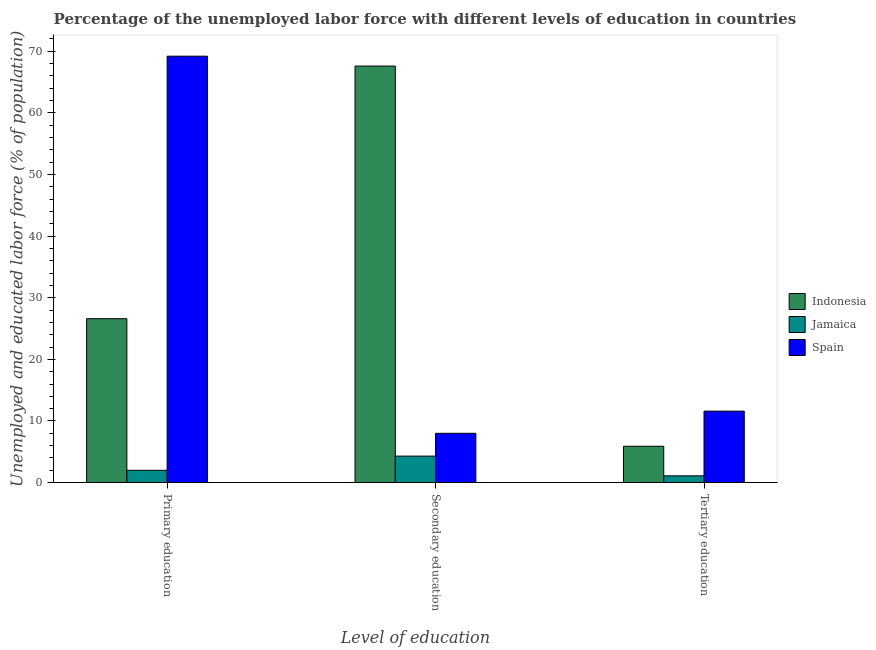How many different coloured bars are there?
Offer a terse response. 3. Are the number of bars per tick equal to the number of legend labels?
Keep it short and to the point. Yes. Are the number of bars on each tick of the X-axis equal?
Keep it short and to the point. Yes. How many bars are there on the 2nd tick from the right?
Offer a very short reply. 3. What is the label of the 3rd group of bars from the left?
Ensure brevity in your answer.  Tertiary education. What is the percentage of labor force who received primary education in Jamaica?
Ensure brevity in your answer.  2. Across all countries, what is the maximum percentage of labor force who received tertiary education?
Offer a very short reply. 11.6. Across all countries, what is the minimum percentage of labor force who received tertiary education?
Make the answer very short. 1.1. In which country was the percentage of labor force who received tertiary education minimum?
Your answer should be very brief. Jamaica. What is the total percentage of labor force who received tertiary education in the graph?
Make the answer very short. 18.6. What is the difference between the percentage of labor force who received tertiary education in Indonesia and that in Jamaica?
Offer a terse response. 4.8. What is the difference between the percentage of labor force who received tertiary education in Indonesia and the percentage of labor force who received secondary education in Jamaica?
Provide a short and direct response. 1.6. What is the average percentage of labor force who received tertiary education per country?
Make the answer very short. 6.2. What is the difference between the percentage of labor force who received tertiary education and percentage of labor force who received primary education in Jamaica?
Make the answer very short. -0.9. In how many countries, is the percentage of labor force who received secondary education greater than 26 %?
Your answer should be very brief. 1. What is the ratio of the percentage of labor force who received secondary education in Indonesia to that in Spain?
Offer a terse response. 8.45. Is the percentage of labor force who received primary education in Indonesia less than that in Jamaica?
Ensure brevity in your answer.  No. What is the difference between the highest and the second highest percentage of labor force who received tertiary education?
Provide a short and direct response. 5.7. What is the difference between the highest and the lowest percentage of labor force who received primary education?
Make the answer very short. 67.2. In how many countries, is the percentage of labor force who received secondary education greater than the average percentage of labor force who received secondary education taken over all countries?
Provide a short and direct response. 1. What does the 3rd bar from the left in Secondary education represents?
Your answer should be compact. Spain. What does the 3rd bar from the right in Primary education represents?
Your answer should be compact. Indonesia. How many bars are there?
Offer a terse response. 9. Are all the bars in the graph horizontal?
Your response must be concise. No. What is the difference between two consecutive major ticks on the Y-axis?
Give a very brief answer. 10. Are the values on the major ticks of Y-axis written in scientific E-notation?
Offer a very short reply. No. Does the graph contain grids?
Make the answer very short. No. Where does the legend appear in the graph?
Make the answer very short. Center right. What is the title of the graph?
Ensure brevity in your answer.  Percentage of the unemployed labor force with different levels of education in countries. Does "Oman" appear as one of the legend labels in the graph?
Ensure brevity in your answer.  No. What is the label or title of the X-axis?
Provide a short and direct response. Level of education. What is the label or title of the Y-axis?
Your answer should be compact. Unemployed and educated labor force (% of population). What is the Unemployed and educated labor force (% of population) in Indonesia in Primary education?
Make the answer very short. 26.6. What is the Unemployed and educated labor force (% of population) of Spain in Primary education?
Give a very brief answer. 69.2. What is the Unemployed and educated labor force (% of population) in Indonesia in Secondary education?
Provide a succinct answer. 67.6. What is the Unemployed and educated labor force (% of population) of Jamaica in Secondary education?
Provide a succinct answer. 4.3. What is the Unemployed and educated labor force (% of population) of Indonesia in Tertiary education?
Provide a succinct answer. 5.9. What is the Unemployed and educated labor force (% of population) in Jamaica in Tertiary education?
Offer a terse response. 1.1. What is the Unemployed and educated labor force (% of population) in Spain in Tertiary education?
Offer a terse response. 11.6. Across all Level of education, what is the maximum Unemployed and educated labor force (% of population) in Indonesia?
Your answer should be compact. 67.6. Across all Level of education, what is the maximum Unemployed and educated labor force (% of population) in Jamaica?
Your answer should be compact. 4.3. Across all Level of education, what is the maximum Unemployed and educated labor force (% of population) of Spain?
Your answer should be very brief. 69.2. Across all Level of education, what is the minimum Unemployed and educated labor force (% of population) of Indonesia?
Keep it short and to the point. 5.9. Across all Level of education, what is the minimum Unemployed and educated labor force (% of population) in Jamaica?
Your response must be concise. 1.1. Across all Level of education, what is the minimum Unemployed and educated labor force (% of population) of Spain?
Provide a short and direct response. 8. What is the total Unemployed and educated labor force (% of population) in Indonesia in the graph?
Provide a succinct answer. 100.1. What is the total Unemployed and educated labor force (% of population) of Spain in the graph?
Offer a terse response. 88.8. What is the difference between the Unemployed and educated labor force (% of population) of Indonesia in Primary education and that in Secondary education?
Your answer should be very brief. -41. What is the difference between the Unemployed and educated labor force (% of population) of Spain in Primary education and that in Secondary education?
Give a very brief answer. 61.2. What is the difference between the Unemployed and educated labor force (% of population) of Indonesia in Primary education and that in Tertiary education?
Offer a terse response. 20.7. What is the difference between the Unemployed and educated labor force (% of population) in Jamaica in Primary education and that in Tertiary education?
Keep it short and to the point. 0.9. What is the difference between the Unemployed and educated labor force (% of population) in Spain in Primary education and that in Tertiary education?
Offer a terse response. 57.6. What is the difference between the Unemployed and educated labor force (% of population) of Indonesia in Secondary education and that in Tertiary education?
Your answer should be very brief. 61.7. What is the difference between the Unemployed and educated labor force (% of population) in Spain in Secondary education and that in Tertiary education?
Make the answer very short. -3.6. What is the difference between the Unemployed and educated labor force (% of population) of Indonesia in Primary education and the Unemployed and educated labor force (% of population) of Jamaica in Secondary education?
Offer a terse response. 22.3. What is the difference between the Unemployed and educated labor force (% of population) of Indonesia in Primary education and the Unemployed and educated labor force (% of population) of Spain in Tertiary education?
Keep it short and to the point. 15. What is the difference between the Unemployed and educated labor force (% of population) of Indonesia in Secondary education and the Unemployed and educated labor force (% of population) of Jamaica in Tertiary education?
Your answer should be compact. 66.5. What is the difference between the Unemployed and educated labor force (% of population) of Indonesia in Secondary education and the Unemployed and educated labor force (% of population) of Spain in Tertiary education?
Provide a short and direct response. 56. What is the average Unemployed and educated labor force (% of population) of Indonesia per Level of education?
Your response must be concise. 33.37. What is the average Unemployed and educated labor force (% of population) of Jamaica per Level of education?
Keep it short and to the point. 2.47. What is the average Unemployed and educated labor force (% of population) in Spain per Level of education?
Your response must be concise. 29.6. What is the difference between the Unemployed and educated labor force (% of population) of Indonesia and Unemployed and educated labor force (% of population) of Jamaica in Primary education?
Your answer should be compact. 24.6. What is the difference between the Unemployed and educated labor force (% of population) in Indonesia and Unemployed and educated labor force (% of population) in Spain in Primary education?
Your answer should be very brief. -42.6. What is the difference between the Unemployed and educated labor force (% of population) of Jamaica and Unemployed and educated labor force (% of population) of Spain in Primary education?
Offer a terse response. -67.2. What is the difference between the Unemployed and educated labor force (% of population) in Indonesia and Unemployed and educated labor force (% of population) in Jamaica in Secondary education?
Your response must be concise. 63.3. What is the difference between the Unemployed and educated labor force (% of population) of Indonesia and Unemployed and educated labor force (% of population) of Spain in Secondary education?
Keep it short and to the point. 59.6. What is the difference between the Unemployed and educated labor force (% of population) of Jamaica and Unemployed and educated labor force (% of population) of Spain in Secondary education?
Give a very brief answer. -3.7. What is the difference between the Unemployed and educated labor force (% of population) in Indonesia and Unemployed and educated labor force (% of population) in Spain in Tertiary education?
Your answer should be compact. -5.7. What is the ratio of the Unemployed and educated labor force (% of population) in Indonesia in Primary education to that in Secondary education?
Keep it short and to the point. 0.39. What is the ratio of the Unemployed and educated labor force (% of population) of Jamaica in Primary education to that in Secondary education?
Provide a short and direct response. 0.47. What is the ratio of the Unemployed and educated labor force (% of population) of Spain in Primary education to that in Secondary education?
Provide a short and direct response. 8.65. What is the ratio of the Unemployed and educated labor force (% of population) in Indonesia in Primary education to that in Tertiary education?
Your response must be concise. 4.51. What is the ratio of the Unemployed and educated labor force (% of population) of Jamaica in Primary education to that in Tertiary education?
Provide a short and direct response. 1.82. What is the ratio of the Unemployed and educated labor force (% of population) in Spain in Primary education to that in Tertiary education?
Your answer should be compact. 5.97. What is the ratio of the Unemployed and educated labor force (% of population) of Indonesia in Secondary education to that in Tertiary education?
Provide a short and direct response. 11.46. What is the ratio of the Unemployed and educated labor force (% of population) in Jamaica in Secondary education to that in Tertiary education?
Your answer should be very brief. 3.91. What is the ratio of the Unemployed and educated labor force (% of population) of Spain in Secondary education to that in Tertiary education?
Make the answer very short. 0.69. What is the difference between the highest and the second highest Unemployed and educated labor force (% of population) in Jamaica?
Keep it short and to the point. 2.3. What is the difference between the highest and the second highest Unemployed and educated labor force (% of population) in Spain?
Ensure brevity in your answer.  57.6. What is the difference between the highest and the lowest Unemployed and educated labor force (% of population) of Indonesia?
Provide a succinct answer. 61.7. What is the difference between the highest and the lowest Unemployed and educated labor force (% of population) in Spain?
Offer a terse response. 61.2. 